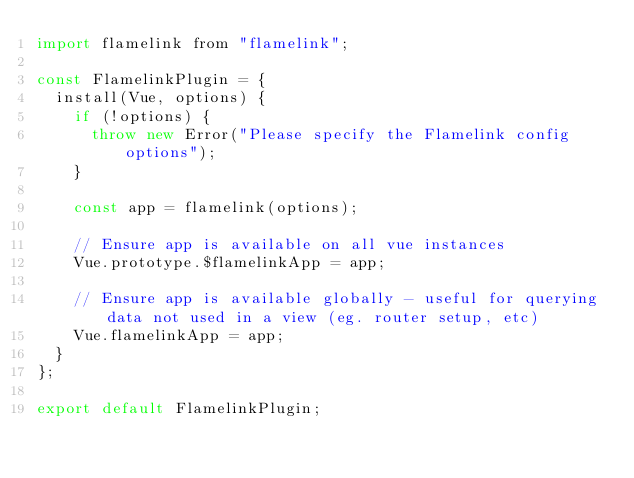Convert code to text. <code><loc_0><loc_0><loc_500><loc_500><_JavaScript_>import flamelink from "flamelink";

const FlamelinkPlugin = {
  install(Vue, options) {
    if (!options) {
      throw new Error("Please specify the Flamelink config options");
    }

    const app = flamelink(options);

    // Ensure app is available on all vue instances
    Vue.prototype.$flamelinkApp = app;

    // Ensure app is available globally - useful for querying data not used in a view (eg. router setup, etc)
    Vue.flamelinkApp = app;
  }
};

export default FlamelinkPlugin;
</code> 